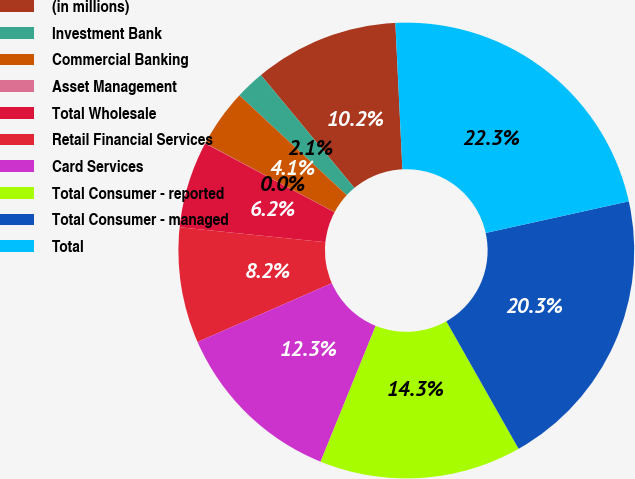Convert chart. <chart><loc_0><loc_0><loc_500><loc_500><pie_chart><fcel>(in millions)<fcel>Investment Bank<fcel>Commercial Banking<fcel>Asset Management<fcel>Total Wholesale<fcel>Retail Financial Services<fcel>Card Services<fcel>Total Consumer - reported<fcel>Total Consumer - managed<fcel>Total<nl><fcel>10.25%<fcel>2.07%<fcel>4.11%<fcel>0.02%<fcel>6.16%<fcel>8.2%<fcel>12.29%<fcel>14.34%<fcel>20.26%<fcel>22.3%<nl></chart> 